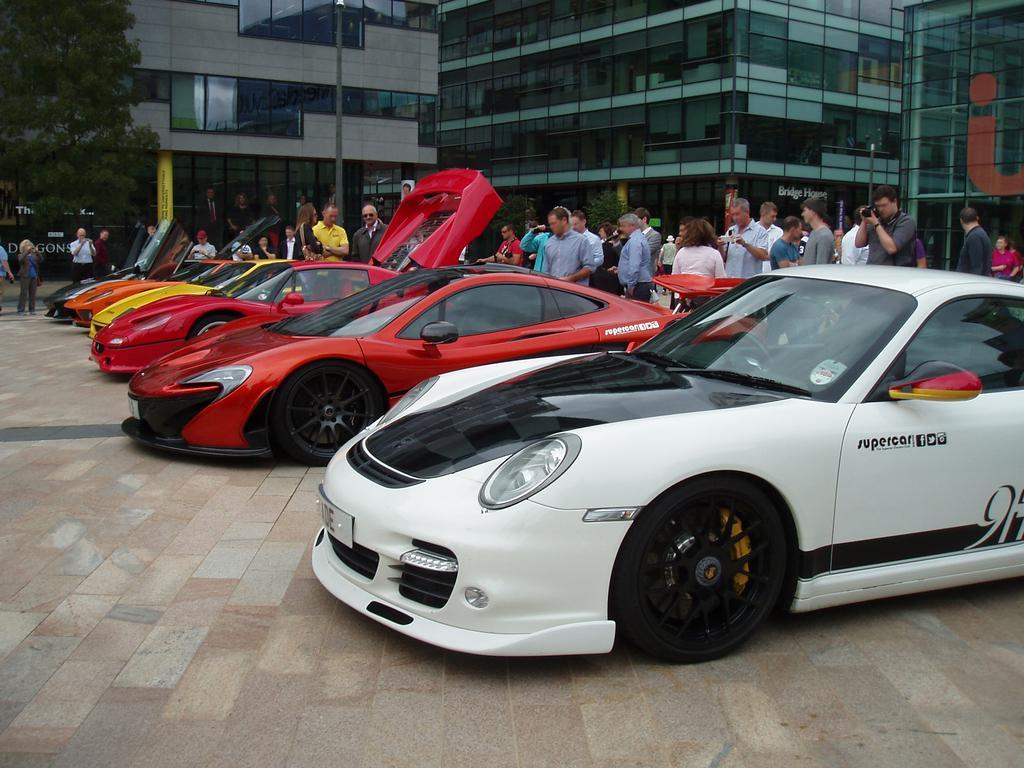Can you describe this image briefly? In this image we can see cars on the road. In the background we can see few persons are standing and among them few persons are holding objects in their hands, trees, poles, buildings, windows and glass doors. 